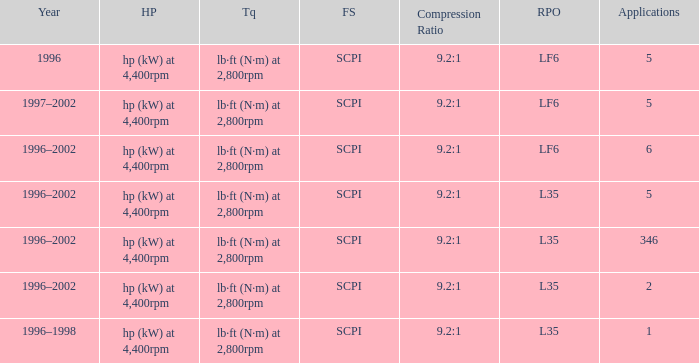What are the torque characteristics of the model with 346 applications? Lb·ft (n·m) at 2,800rpm. 